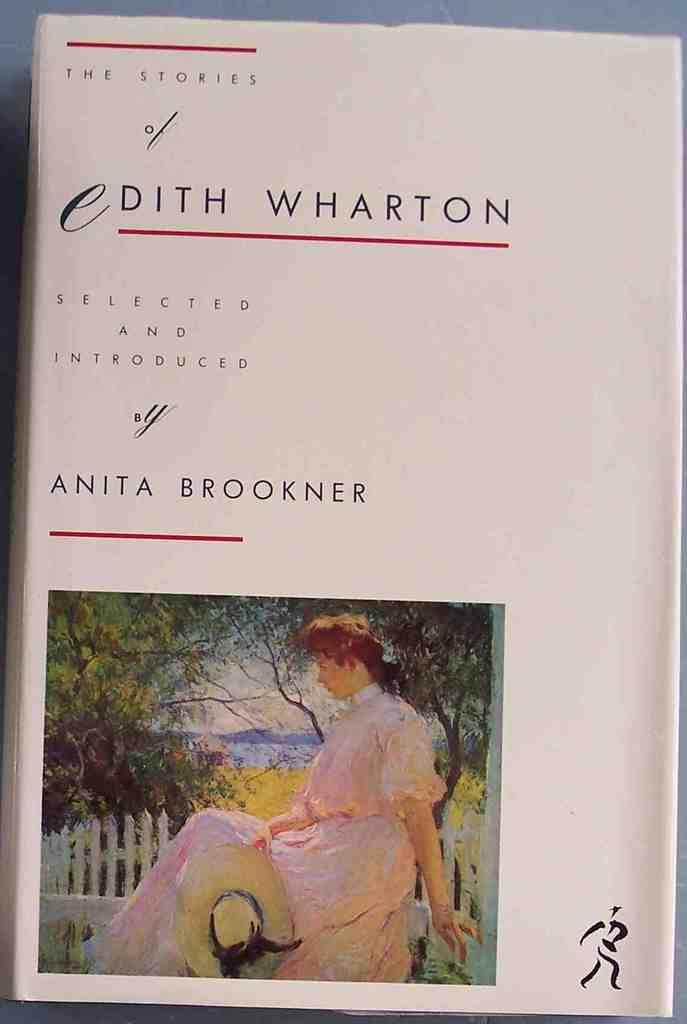Provide a one-sentence caption for the provided image. The cover of The Stories of Edith Wharton features an impressionist painting of a woman. 